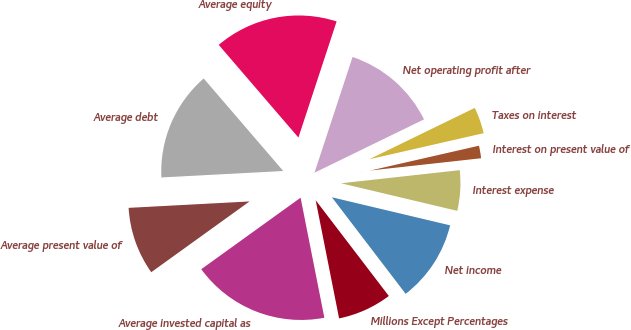<chart> <loc_0><loc_0><loc_500><loc_500><pie_chart><fcel>Millions Except Percentages<fcel>Net income<fcel>Interest expense<fcel>Interest on present value of<fcel>Taxes on interest<fcel>Net operating profit after<fcel>Average equity<fcel>Average debt<fcel>Average present value of<fcel>Average invested capital as<nl><fcel>7.27%<fcel>10.91%<fcel>5.46%<fcel>1.82%<fcel>3.64%<fcel>12.73%<fcel>16.36%<fcel>14.54%<fcel>9.09%<fcel>18.18%<nl></chart> 